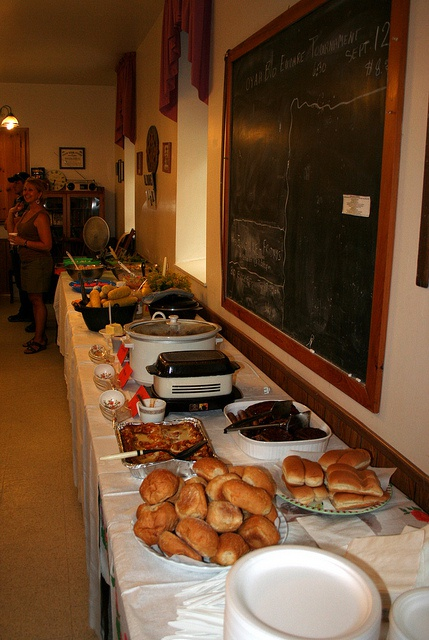Describe the objects in this image and their specific colors. I can see dining table in maroon, brown, darkgray, black, and lightgray tones, people in maroon, black, and brown tones, bowl in maroon, black, darkgray, and gray tones, bowl in maroon, black, tan, and gray tones, and cup in maroon, brown, tan, and gray tones in this image. 